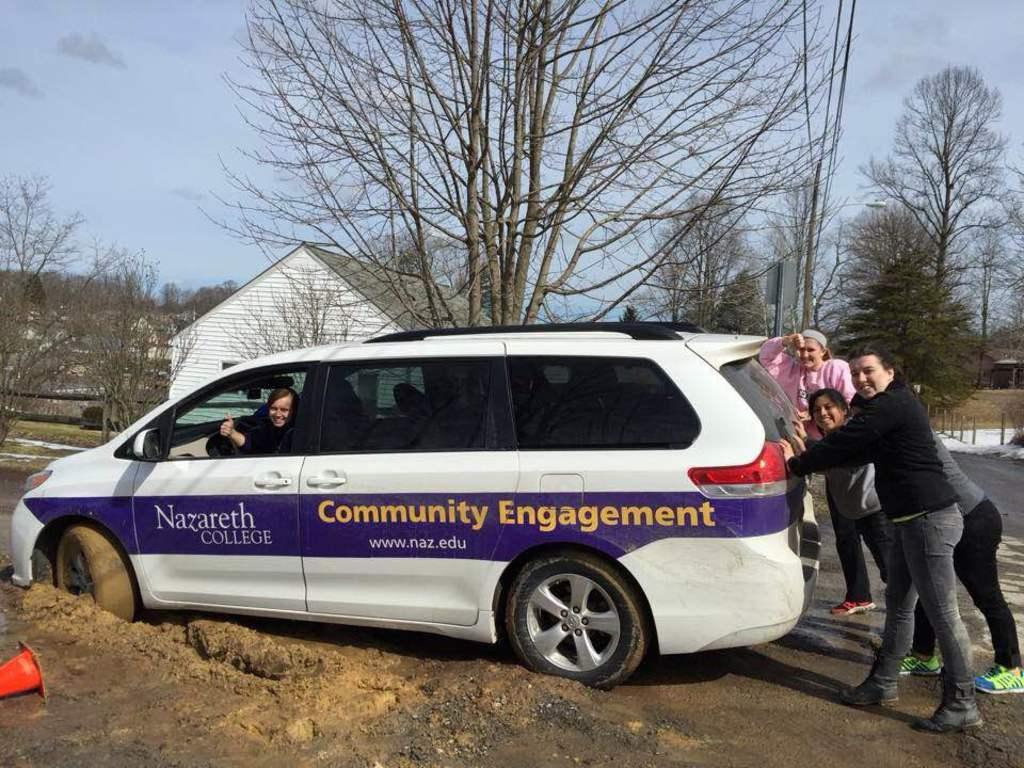What are the persons in the image doing? The persons in the image are trying to push a car. Who is inside the car? A woman is seated in the car. What can be seen in the background of the image? There is a building and trees in the background of the image. What type of underwear is the woman wearing in the image? There is no information about the woman's underwear in the image, so it cannot be determined. 